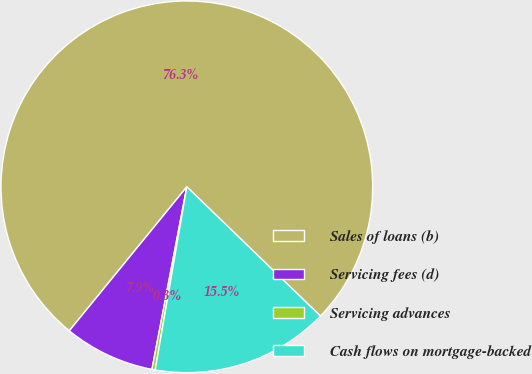Convert chart. <chart><loc_0><loc_0><loc_500><loc_500><pie_chart><fcel>Sales of loans (b)<fcel>Servicing fees (d)<fcel>Servicing advances<fcel>Cash flows on mortgage-backed<nl><fcel>76.34%<fcel>7.89%<fcel>0.28%<fcel>15.49%<nl></chart> 